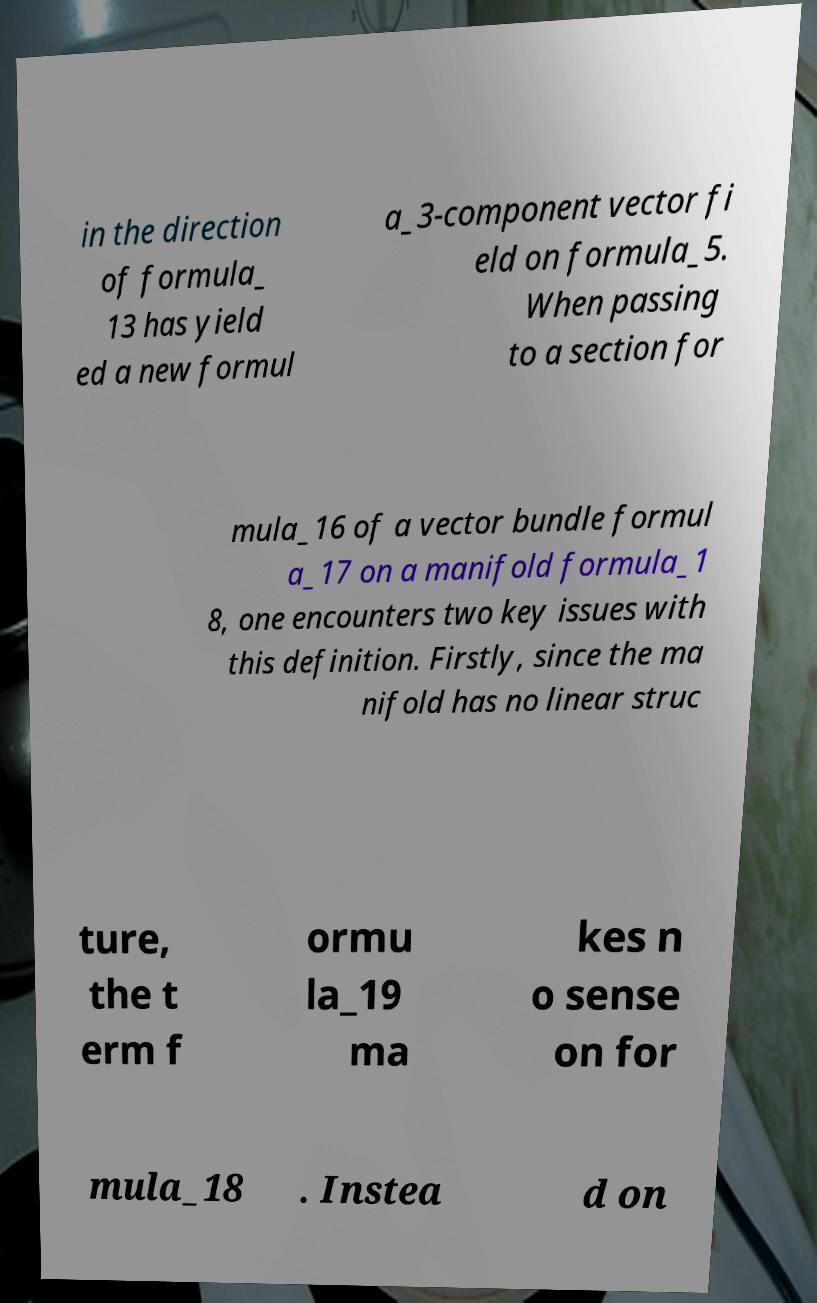Please identify and transcribe the text found in this image. in the direction of formula_ 13 has yield ed a new formul a_3-component vector fi eld on formula_5. When passing to a section for mula_16 of a vector bundle formul a_17 on a manifold formula_1 8, one encounters two key issues with this definition. Firstly, since the ma nifold has no linear struc ture, the t erm f ormu la_19 ma kes n o sense on for mula_18 . Instea d on 